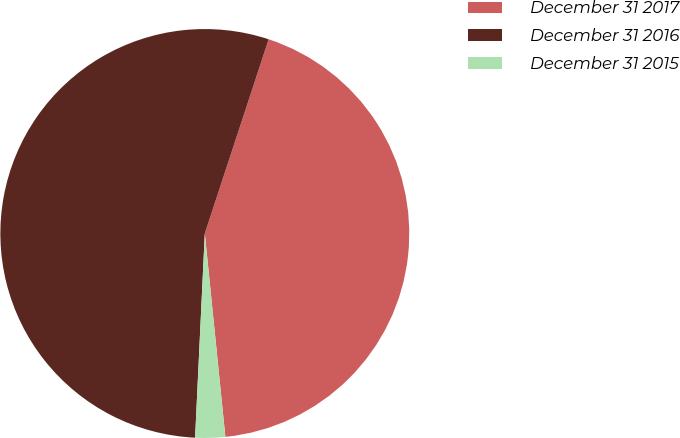<chart> <loc_0><loc_0><loc_500><loc_500><pie_chart><fcel>December 31 2017<fcel>December 31 2016<fcel>December 31 2015<nl><fcel>43.34%<fcel>54.3%<fcel>2.36%<nl></chart> 